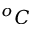Convert formula to latex. <formula><loc_0><loc_0><loc_500><loc_500>^ { o } C</formula> 